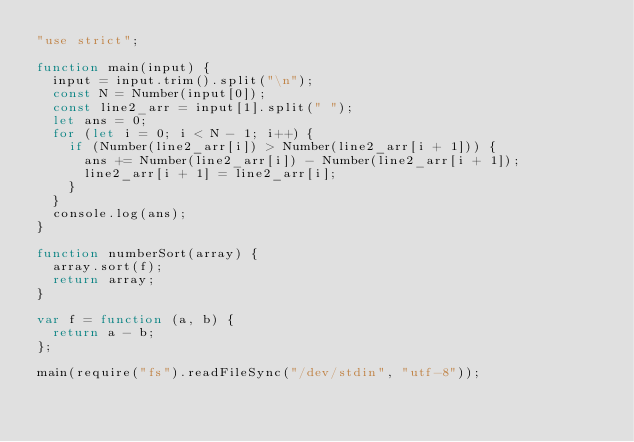<code> <loc_0><loc_0><loc_500><loc_500><_JavaScript_>"use strict";

function main(input) {
  input = input.trim().split("\n");
  const N = Number(input[0]);
  const line2_arr = input[1].split(" ");
  let ans = 0;
  for (let i = 0; i < N - 1; i++) {
    if (Number(line2_arr[i]) > Number(line2_arr[i + 1])) {
      ans += Number(line2_arr[i]) - Number(line2_arr[i + 1]);
      line2_arr[i + 1] = line2_arr[i];
    }
  }
  console.log(ans);
}

function numberSort(array) {
  array.sort(f);
  return array;
}

var f = function (a, b) {
  return a - b;
};

main(require("fs").readFileSync("/dev/stdin", "utf-8"));
</code> 